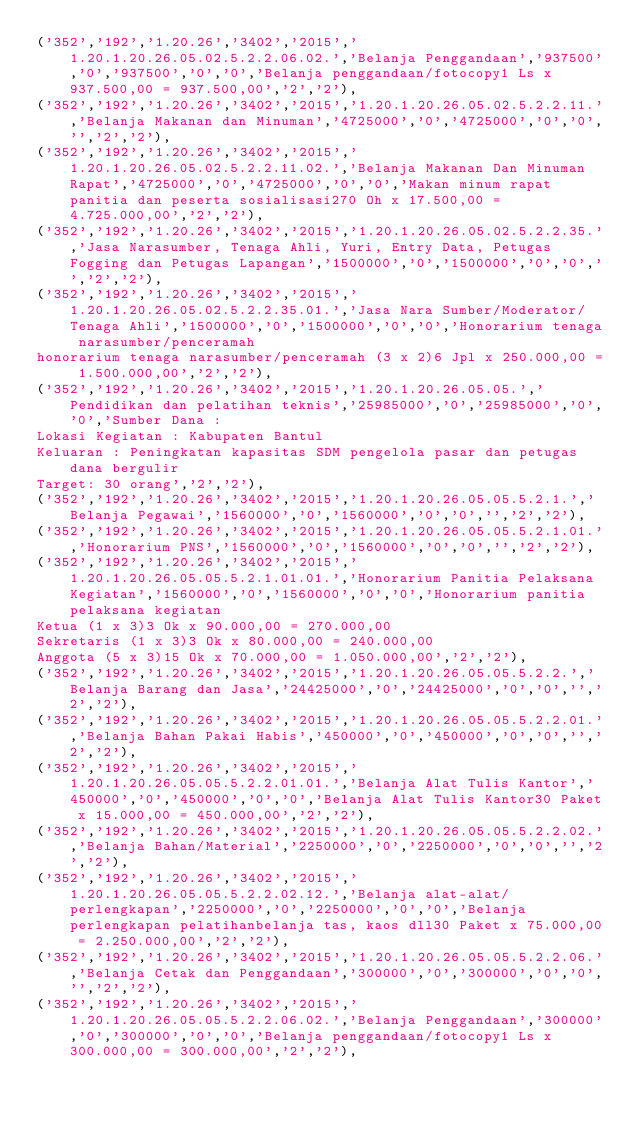Convert code to text. <code><loc_0><loc_0><loc_500><loc_500><_SQL_>('352','192','1.20.26','3402','2015','1.20.1.20.26.05.02.5.2.2.06.02.','Belanja Penggandaan','937500','0','937500','0','0','Belanja penggandaan/fotocopy1 Ls x 937.500,00 = 937.500,00','2','2'),
('352','192','1.20.26','3402','2015','1.20.1.20.26.05.02.5.2.2.11.','Belanja Makanan dan Minuman','4725000','0','4725000','0','0','','2','2'),
('352','192','1.20.26','3402','2015','1.20.1.20.26.05.02.5.2.2.11.02.','Belanja Makanan Dan Minuman Rapat','4725000','0','4725000','0','0','Makan minum rapat panitia dan peserta sosialisasi270 Oh x 17.500,00 = 4.725.000,00','2','2'),
('352','192','1.20.26','3402','2015','1.20.1.20.26.05.02.5.2.2.35.','Jasa Narasumber, Tenaga Ahli, Yuri, Entry Data, Petugas Fogging dan Petugas Lapangan','1500000','0','1500000','0','0','','2','2'),
('352','192','1.20.26','3402','2015','1.20.1.20.26.05.02.5.2.2.35.01.','Jasa Nara Sumber/Moderator/Tenaga Ahli','1500000','0','1500000','0','0','Honorarium tenaga narasumber/penceramah
honorarium tenaga narasumber/penceramah (3 x 2)6 Jpl x 250.000,00 = 1.500.000,00','2','2'),
('352','192','1.20.26','3402','2015','1.20.1.20.26.05.05.','Pendidikan dan pelatihan teknis','25985000','0','25985000','0','0','Sumber Dana : 
Lokasi Kegiatan : Kabupaten Bantul
Keluaran : Peningkatan kapasitas SDM pengelola pasar dan petugas dana bergulir
Target: 30 orang','2','2'),
('352','192','1.20.26','3402','2015','1.20.1.20.26.05.05.5.2.1.','Belanja Pegawai','1560000','0','1560000','0','0','','2','2'),
('352','192','1.20.26','3402','2015','1.20.1.20.26.05.05.5.2.1.01.','Honorarium PNS','1560000','0','1560000','0','0','','2','2'),
('352','192','1.20.26','3402','2015','1.20.1.20.26.05.05.5.2.1.01.01.','Honorarium Panitia Pelaksana Kegiatan','1560000','0','1560000','0','0','Honorarium panitia pelaksana kegiatan
Ketua (1 x 3)3 Ok x 90.000,00 = 270.000,00
Sekretaris (1 x 3)3 Ok x 80.000,00 = 240.000,00
Anggota (5 x 3)15 Ok x 70.000,00 = 1.050.000,00','2','2'),
('352','192','1.20.26','3402','2015','1.20.1.20.26.05.05.5.2.2.','Belanja Barang dan Jasa','24425000','0','24425000','0','0','','2','2'),
('352','192','1.20.26','3402','2015','1.20.1.20.26.05.05.5.2.2.01.','Belanja Bahan Pakai Habis','450000','0','450000','0','0','','2','2'),
('352','192','1.20.26','3402','2015','1.20.1.20.26.05.05.5.2.2.01.01.','Belanja Alat Tulis Kantor','450000','0','450000','0','0','Belanja Alat Tulis Kantor30 Paket x 15.000,00 = 450.000,00','2','2'),
('352','192','1.20.26','3402','2015','1.20.1.20.26.05.05.5.2.2.02.','Belanja Bahan/Material','2250000','0','2250000','0','0','','2','2'),
('352','192','1.20.26','3402','2015','1.20.1.20.26.05.05.5.2.2.02.12.','Belanja alat-alat/perlengkapan','2250000','0','2250000','0','0','Belanja perlengkapan pelatihanbelanja tas, kaos dll30 Paket x 75.000,00 = 2.250.000,00','2','2'),
('352','192','1.20.26','3402','2015','1.20.1.20.26.05.05.5.2.2.06.','Belanja Cetak dan Penggandaan','300000','0','300000','0','0','','2','2'),
('352','192','1.20.26','3402','2015','1.20.1.20.26.05.05.5.2.2.06.02.','Belanja Penggandaan','300000','0','300000','0','0','Belanja penggandaan/fotocopy1 Ls x 300.000,00 = 300.000,00','2','2'),</code> 